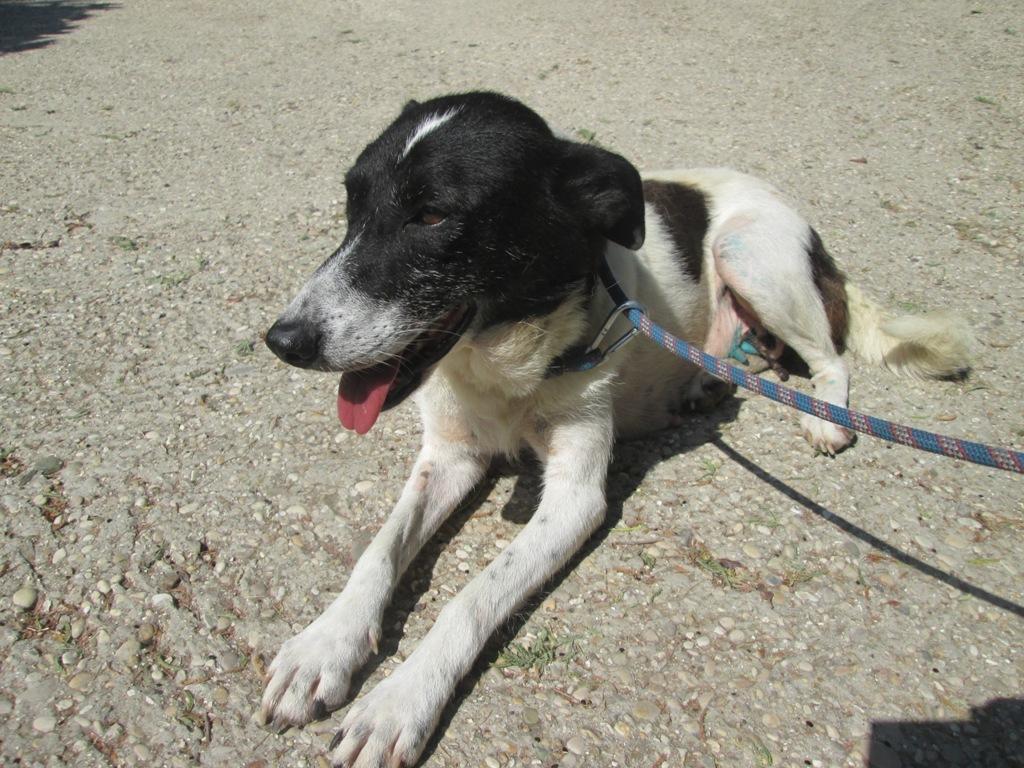Please provide a concise description of this image. In this image we can see a dog sitting on the ground, and wearing a belt. 